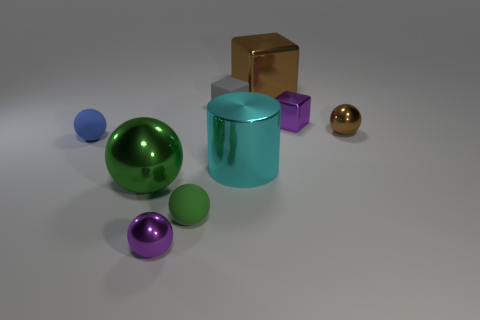Are there any other things that are the same shape as the small gray object?
Ensure brevity in your answer.  Yes. What number of large blocks are there?
Ensure brevity in your answer.  1. How many yellow things are either rubber spheres or tiny cylinders?
Your answer should be compact. 0. Does the small purple thing left of the large cyan metal cylinder have the same material as the large cylinder?
Keep it short and to the point. Yes. How many other things are there of the same material as the gray block?
Offer a very short reply. 2. What is the material of the blue thing?
Your answer should be compact. Rubber. There is a shiny ball that is on the right side of the tiny green ball; how big is it?
Your response must be concise. Small. How many tiny blue balls are on the right side of the small ball that is on the left side of the purple sphere?
Keep it short and to the point. 0. Does the tiny purple shiny thing that is on the right side of the rubber cube have the same shape as the small green matte thing in front of the green shiny sphere?
Provide a succinct answer. No. How many small matte objects are on the left side of the tiny gray thing and to the right of the tiny blue sphere?
Provide a succinct answer. 1. 